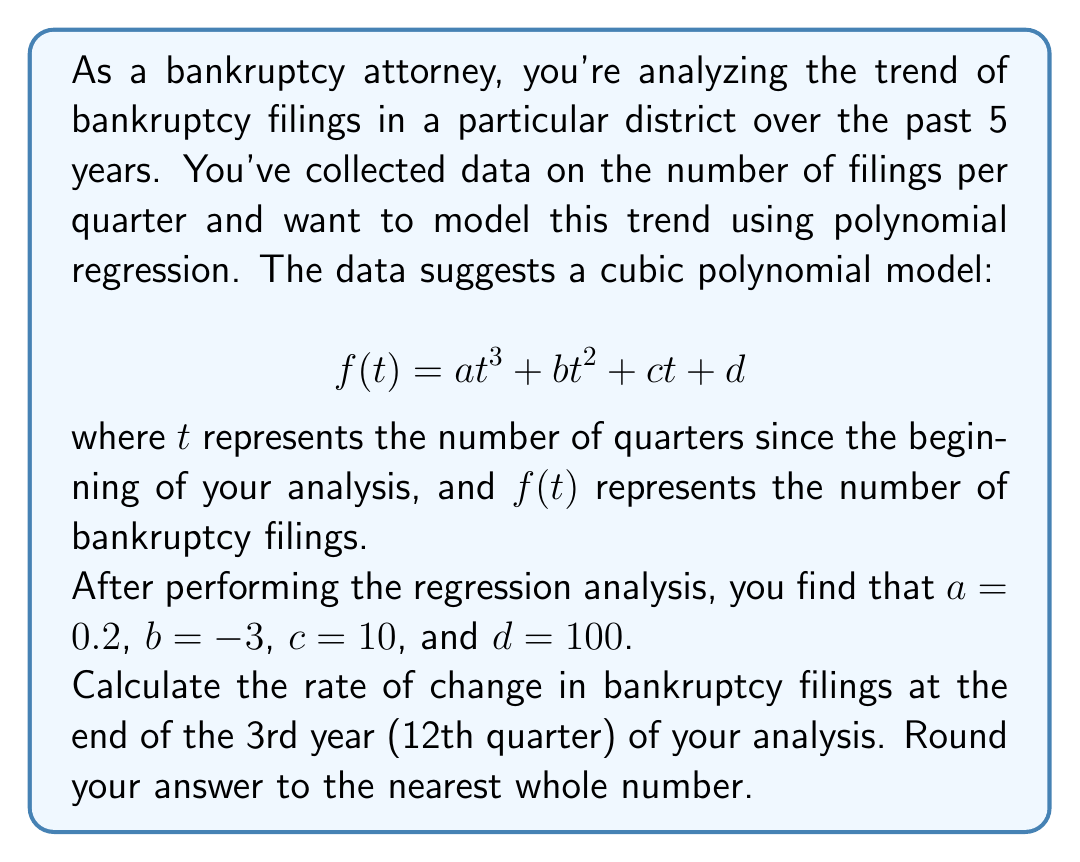Can you solve this math problem? To solve this problem, we need to follow these steps:

1) The given polynomial function is:
   $$f(t) = 0.2t^3 - 3t^2 + 10t + 100$$

2) To find the rate of change, we need to calculate the first derivative of this function:
   $$f'(t) = 0.6t^2 - 6t + 10$$

3) We want to find the rate of change at the end of the 3rd year, which is the 12th quarter. So we need to evaluate $f'(12)$:

   $$f'(12) = 0.6(12)^2 - 6(12) + 10$$
   
   $$= 0.6(144) - 72 + 10$$
   
   $$= 86.4 - 72 + 10$$
   
   $$= 24.4$$

4) Rounding to the nearest whole number:
   24.4 rounds to 24

This means that at the end of the 3rd year, the rate of bankruptcy filings was increasing by approximately 24 filings per quarter.
Answer: 24 filings per quarter 